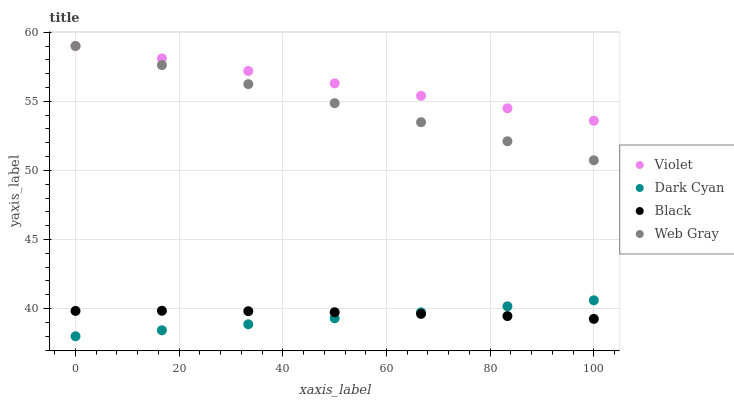Does Dark Cyan have the minimum area under the curve?
Answer yes or no. Yes. Does Violet have the maximum area under the curve?
Answer yes or no. Yes. Does Web Gray have the minimum area under the curve?
Answer yes or no. No. Does Web Gray have the maximum area under the curve?
Answer yes or no. No. Is Web Gray the smoothest?
Answer yes or no. Yes. Is Black the roughest?
Answer yes or no. Yes. Is Black the smoothest?
Answer yes or no. No. Is Web Gray the roughest?
Answer yes or no. No. Does Dark Cyan have the lowest value?
Answer yes or no. Yes. Does Web Gray have the lowest value?
Answer yes or no. No. Does Violet have the highest value?
Answer yes or no. Yes. Does Black have the highest value?
Answer yes or no. No. Is Black less than Violet?
Answer yes or no. Yes. Is Violet greater than Dark Cyan?
Answer yes or no. Yes. Does Web Gray intersect Violet?
Answer yes or no. Yes. Is Web Gray less than Violet?
Answer yes or no. No. Is Web Gray greater than Violet?
Answer yes or no. No. Does Black intersect Violet?
Answer yes or no. No. 